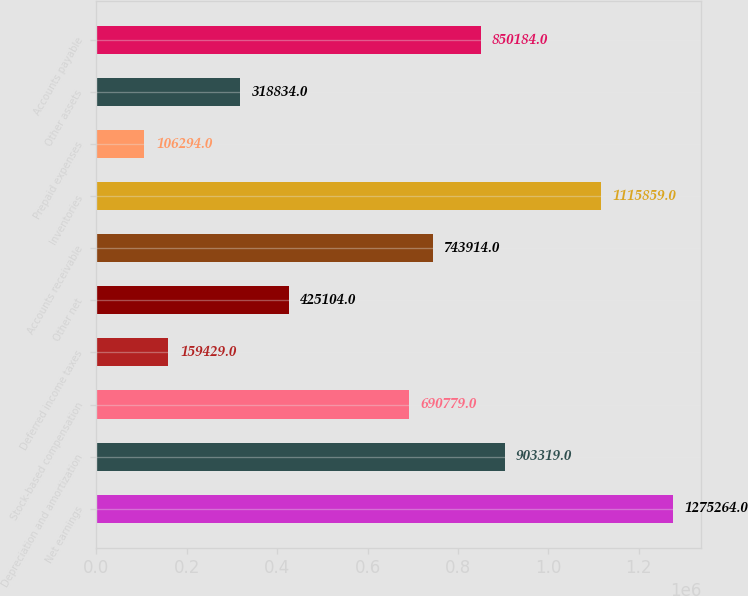Convert chart to OTSL. <chart><loc_0><loc_0><loc_500><loc_500><bar_chart><fcel>Net earnings<fcel>Depreciation and amortization<fcel>Stock-based compensation<fcel>Deferred income taxes<fcel>Other net<fcel>Accounts receivable<fcel>Inventories<fcel>Prepaid expenses<fcel>Other assets<fcel>Accounts payable<nl><fcel>1.27526e+06<fcel>903319<fcel>690779<fcel>159429<fcel>425104<fcel>743914<fcel>1.11586e+06<fcel>106294<fcel>318834<fcel>850184<nl></chart> 